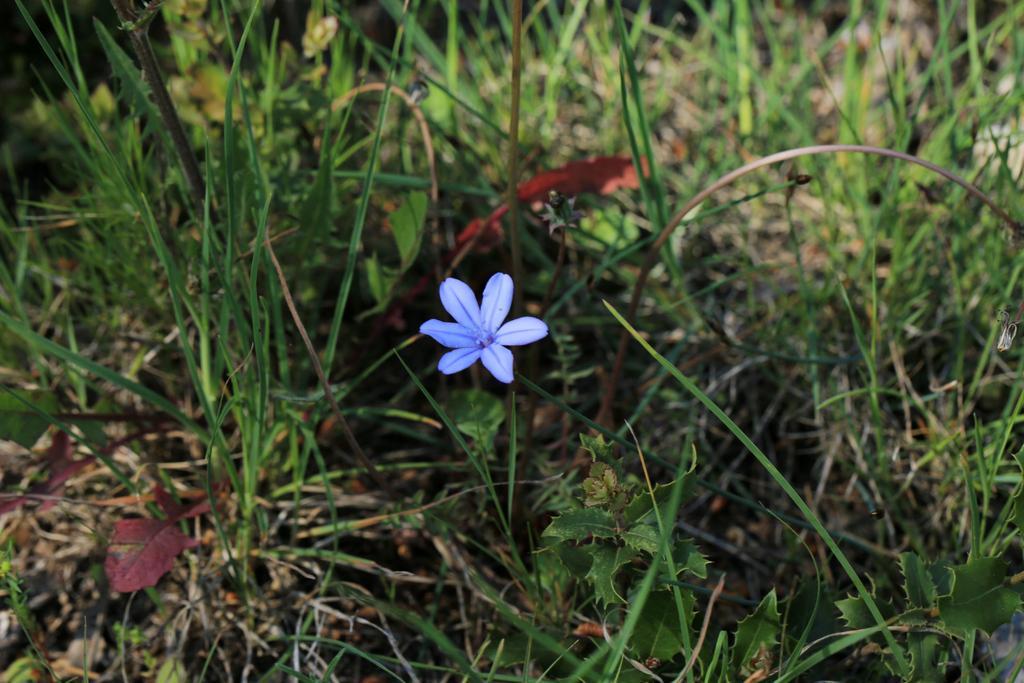Please provide a concise description of this image. In this image we can see the grass, plants and a flower. 